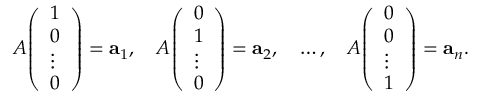<formula> <loc_0><loc_0><loc_500><loc_500>A { \left ( \begin{array} { l } { 1 } \\ { 0 } \\ { \vdots } \\ { 0 } \end{array} \right ) } = a _ { 1 } , \quad A { \left ( \begin{array} { l } { 0 } \\ { 1 } \\ { \vdots } \\ { 0 } \end{array} \right ) } = a _ { 2 } , \quad \dots , \quad A { \left ( \begin{array} { l } { 0 } \\ { 0 } \\ { \vdots } \\ { 1 } \end{array} \right ) } = a _ { n } .</formula> 